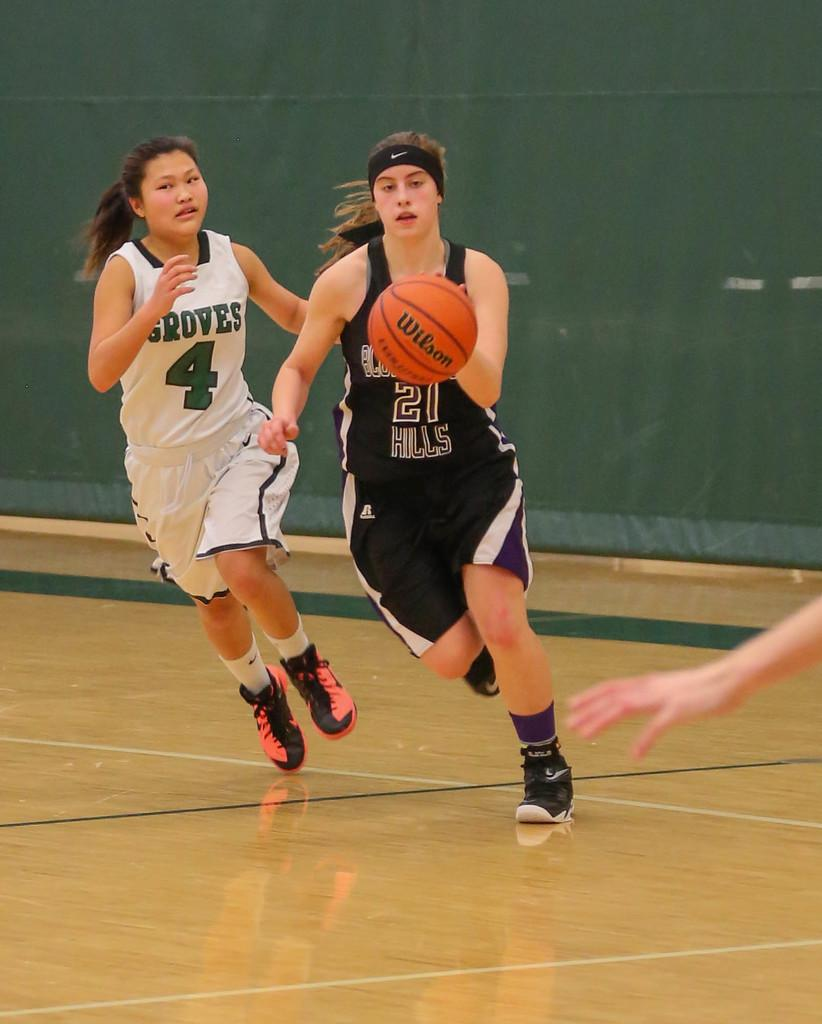<image>
Create a compact narrative representing the image presented. A Groves player wearing number 4 chasing another girl wearing 21 who is dribbling a basketball. 